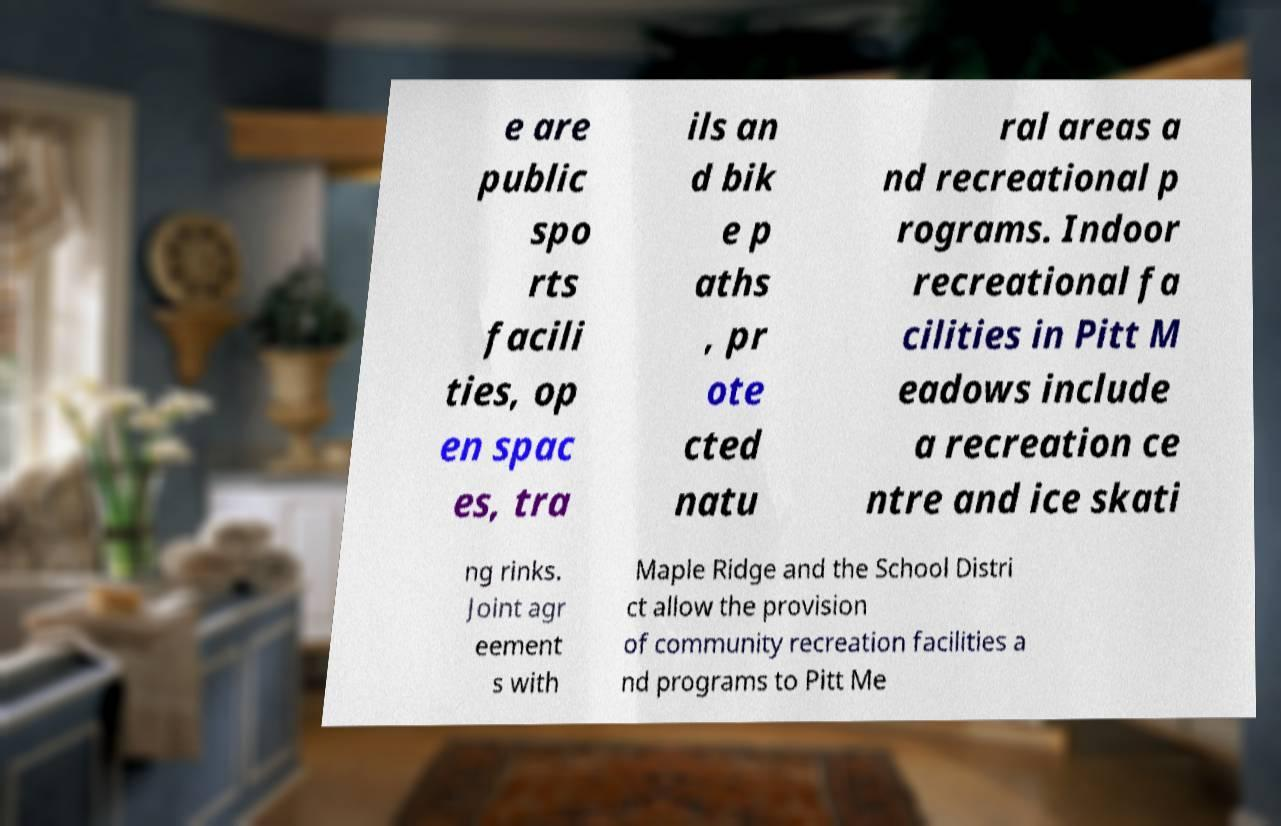For documentation purposes, I need the text within this image transcribed. Could you provide that? e are public spo rts facili ties, op en spac es, tra ils an d bik e p aths , pr ote cted natu ral areas a nd recreational p rograms. Indoor recreational fa cilities in Pitt M eadows include a recreation ce ntre and ice skati ng rinks. Joint agr eement s with Maple Ridge and the School Distri ct allow the provision of community recreation facilities a nd programs to Pitt Me 